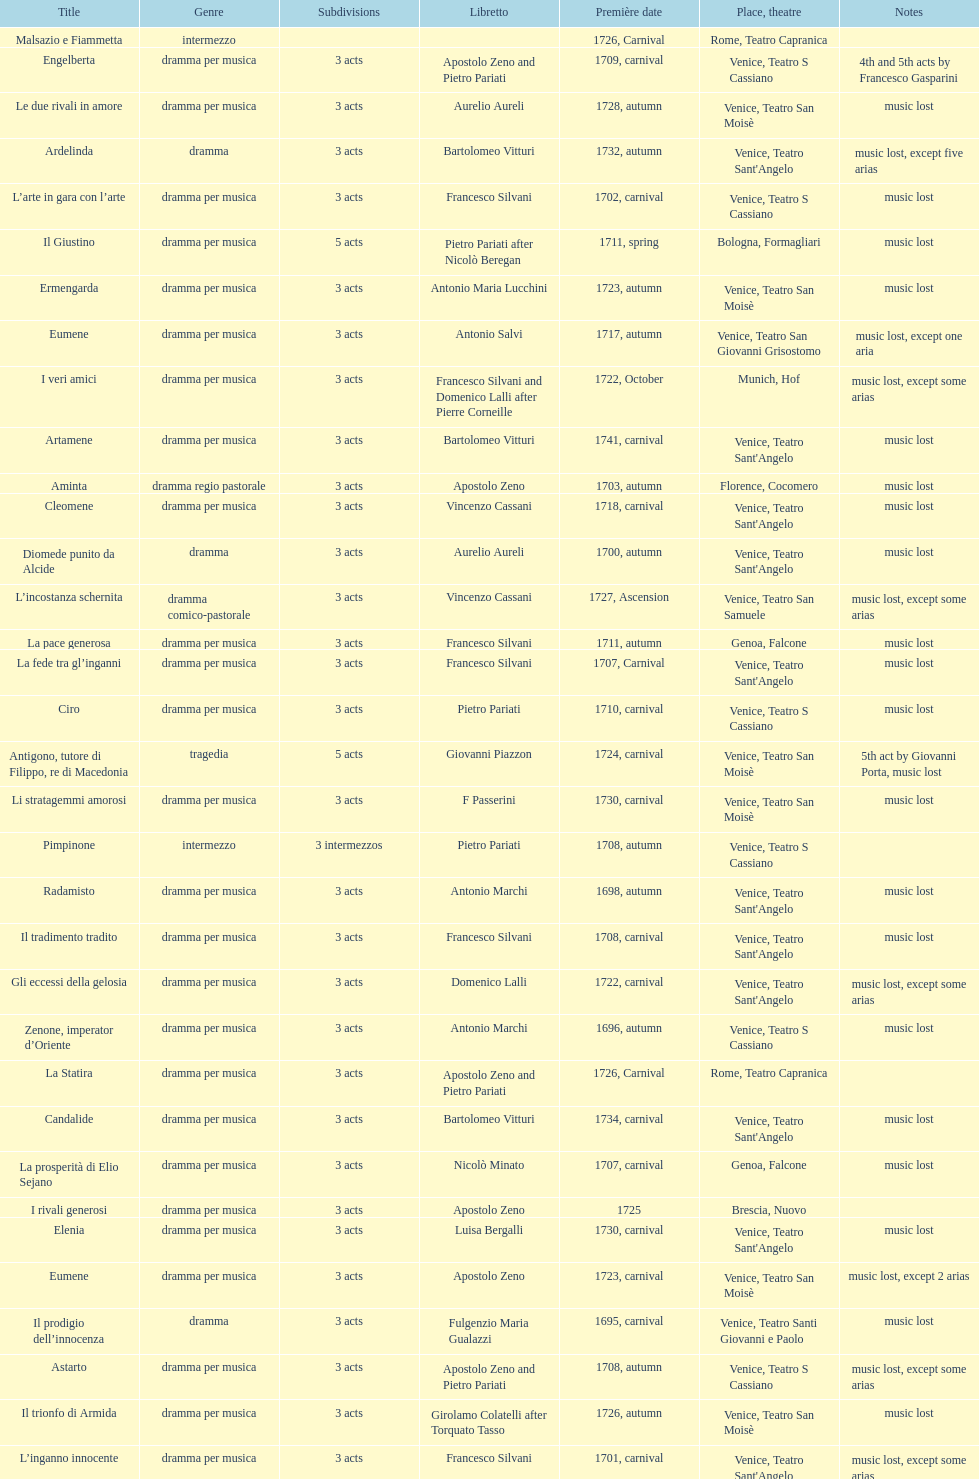Which opera has at least 5 acts? Il Giustino. Help me parse the entirety of this table. {'header': ['Title', 'Genre', 'Sub\xaddivisions', 'Libretto', 'Première date', 'Place, theatre', 'Notes'], 'rows': [['Malsazio e Fiammetta', 'intermezzo', '', '', '1726, Carnival', 'Rome, Teatro Capranica', ''], ['Engelberta', 'dramma per musica', '3 acts', 'Apostolo Zeno and Pietro Pariati', '1709, carnival', 'Venice, Teatro S Cassiano', '4th and 5th acts by Francesco Gasparini'], ['Le due rivali in amore', 'dramma per musica', '3 acts', 'Aurelio Aureli', '1728, autumn', 'Venice, Teatro San Moisè', 'music lost'], ['Ardelinda', 'dramma', '3 acts', 'Bartolomeo Vitturi', '1732, autumn', "Venice, Teatro Sant'Angelo", 'music lost, except five arias'], ['L’arte in gara con l’arte', 'dramma per musica', '3 acts', 'Francesco Silvani', '1702, carnival', 'Venice, Teatro S Cassiano', 'music lost'], ['Il Giustino', 'dramma per musica', '5 acts', 'Pietro Pariati after Nicolò Beregan', '1711, spring', 'Bologna, Formagliari', 'music lost'], ['Ermengarda', 'dramma per musica', '3 acts', 'Antonio Maria Lucchini', '1723, autumn', 'Venice, Teatro San Moisè', 'music lost'], ['Eumene', 'dramma per musica', '3 acts', 'Antonio Salvi', '1717, autumn', 'Venice, Teatro San Giovanni Grisostomo', 'music lost, except one aria'], ['I veri amici', 'dramma per musica', '3 acts', 'Francesco Silvani and Domenico Lalli after Pierre Corneille', '1722, October', 'Munich, Hof', 'music lost, except some arias'], ['Artamene', 'dramma per musica', '3 acts', 'Bartolomeo Vitturi', '1741, carnival', "Venice, Teatro Sant'Angelo", 'music lost'], ['Aminta', 'dramma regio pastorale', '3 acts', 'Apostolo Zeno', '1703, autumn', 'Florence, Cocomero', 'music lost'], ['Cleomene', 'dramma per musica', '3 acts', 'Vincenzo Cassani', '1718, carnival', "Venice, Teatro Sant'Angelo", 'music lost'], ['Diomede punito da Alcide', 'dramma', '3 acts', 'Aurelio Aureli', '1700, autumn', "Venice, Teatro Sant'Angelo", 'music lost'], ['L’incostanza schernita', 'dramma comico-pastorale', '3 acts', 'Vincenzo Cassani', '1727, Ascension', 'Venice, Teatro San Samuele', 'music lost, except some arias'], ['La pace generosa', 'dramma per musica', '3 acts', 'Francesco Silvani', '1711, autumn', 'Genoa, Falcone', 'music lost'], ['La fede tra gl’inganni', 'dramma per musica', '3 acts', 'Francesco Silvani', '1707, Carnival', "Venice, Teatro Sant'Angelo", 'music lost'], ['Ciro', 'dramma per musica', '3 acts', 'Pietro Pariati', '1710, carnival', 'Venice, Teatro S Cassiano', 'music lost'], ['Antigono, tutore di Filippo, re di Macedonia', 'tragedia', '5 acts', 'Giovanni Piazzon', '1724, carnival', 'Venice, Teatro San Moisè', '5th act by Giovanni Porta, music lost'], ['Li stratagemmi amorosi', 'dramma per musica', '3 acts', 'F Passerini', '1730, carnival', 'Venice, Teatro San Moisè', 'music lost'], ['Pimpinone', 'intermezzo', '3 intermezzos', 'Pietro Pariati', '1708, autumn', 'Venice, Teatro S Cassiano', ''], ['Radamisto', 'dramma per musica', '3 acts', 'Antonio Marchi', '1698, autumn', "Venice, Teatro Sant'Angelo", 'music lost'], ['Il tradimento tradito', 'dramma per musica', '3 acts', 'Francesco Silvani', '1708, carnival', "Venice, Teatro Sant'Angelo", 'music lost'], ['Gli eccessi della gelosia', 'dramma per musica', '3 acts', 'Domenico Lalli', '1722, carnival', "Venice, Teatro Sant'Angelo", 'music lost, except some arias'], ['Zenone, imperator d’Oriente', 'dramma per musica', '3 acts', 'Antonio Marchi', '1696, autumn', 'Venice, Teatro S Cassiano', 'music lost'], ['La Statira', 'dramma per musica', '3 acts', 'Apostolo Zeno and Pietro Pariati', '1726, Carnival', 'Rome, Teatro Capranica', ''], ['Candalide', 'dramma per musica', '3 acts', 'Bartolomeo Vitturi', '1734, carnival', "Venice, Teatro Sant'Angelo", 'music lost'], ['La prosperità di Elio Sejano', 'dramma per musica', '3 acts', 'Nicolò Minato', '1707, carnival', 'Genoa, Falcone', 'music lost'], ['I rivali generosi', 'dramma per musica', '3 acts', 'Apostolo Zeno', '1725', 'Brescia, Nuovo', ''], ['Elenia', 'dramma per musica', '3 acts', 'Luisa Bergalli', '1730, carnival', "Venice, Teatro Sant'Angelo", 'music lost'], ['Eumene', 'dramma per musica', '3 acts', 'Apostolo Zeno', '1723, carnival', 'Venice, Teatro San Moisè', 'music lost, except 2 arias'], ['Il prodigio dell’innocenza', 'dramma', '3 acts', 'Fulgenzio Maria Gualazzi', '1695, carnival', 'Venice, Teatro Santi Giovanni e Paolo', 'music lost'], ['Astarto', 'dramma per musica', '3 acts', 'Apostolo Zeno and Pietro Pariati', '1708, autumn', 'Venice, Teatro S Cassiano', 'music lost, except some arias'], ['Il trionfo di Armida', 'dramma per musica', '3 acts', 'Girolamo Colatelli after Torquato Tasso', '1726, autumn', 'Venice, Teatro San Moisè', 'music lost'], ['L’inganno innocente', 'dramma per musica', '3 acts', 'Francesco Silvani', '1701, carnival', "Venice, Teatro Sant'Angelo", 'music lost, except some arias'], ['Il trionfo d’amore', 'dramma per musica', '3 acts', 'Pietro Pariati', '1722, November', 'Munich', 'music lost'], ['Zenobia, regina de’ Palmireni', 'dramma per musica', '3 acts', 'Antonio Marchi', '1694, carnival', 'Venice, Teatro Santi Giovanni e Paolo', 'version of the score survives in Library of Congress, Washington'], ['Merope', 'dramma', '3 acts', 'Apostolo Zeno', '1731, autumn', 'Prague, Sporck Theater', 'mostly by Albinoni, music lost'], ["L'impresario delle Isole Canarie", 'intermezzo', '2 acts', 'Metastasio', '1725, carnival', 'Venice, Teatro S Cassiano', 'music lost'], ['Il Tigrane, re d’Armenia', 'dramma per musica', '3 acts', 'Giulio Cesare Corradi', '1697, carnival', 'Venice, Teatro S Cassiano', 'music lost'], ['Il tiranno eroe', 'dramma per musica', '3 acts', 'Vincenzo Cassani', '1711, carnival', 'Venice, Teatro S Cassiano', ''], ['Lucio Vero', 'dramma per musica', '3 acts', 'Apostolo Zeno', '1713, spring', 'Ferrara, S Stefano', 'music lost'], ['Meleagro', 'dramma per musica', '3 acts', 'Pietro Antonio Bernardoni', '1718, carnival', "Venice, Teatro Sant'Angelo", 'music lost'], ['Primislao, primo re di Boemia', 'dramma per musica', '3 acts', 'Giulio Cesare Corradi', '1697, autumn', 'Venice, Teatro S Cassiano', 'music lost'], ['Didone abbandonata', 'tragedia', '3 acts', 'Metastasio', '1725, carnival', 'Venice, Teatro S Cassiano', 'music lost'], ['Alcina delusa da Ruggero', 'dramma per musica', '3 acts', 'Antonio Marchi', '1725, autumn', 'Venice, Teatro S Cassiano', 'music lost'], ['Il più fedel tra i vassalli', 'dramma per musica', '3 acts', 'Francesco Silvani', '1705, autumn', 'Genoa, Falcone', 'music lost'], ['La fortezza al cimento', 'melodramma', '2 acts', 'Francesco Silvani', '1707', 'Piacenza, Ducale', 'music lost'], ["L'amor di figlio non conosciuto", 'dramma per musica', '3 acts', 'Domenico Lalli', '1716, carnival', "Venice, Teatro Sant'Angelo", 'music lost'], ['L’ingratitudine castigata', 'dramma per musica', '3 acts', 'Francesco Silvani', '1698, carnival', 'Venice, Teatro S Cassiano', 'music lost'], ['Il più infedel tra gli amanti', 'dramma per musica', '3 acts', 'Angelo Schietti', '1731, autumn', 'Treviso, Dolphin', 'music lost'], ['Laodice', 'dramma per musica', '3 acts', 'Angelo Schietti', '1724, autumn', 'Venice, Teatro San Moisè', 'music lost, except 2 arias'], ['Il Satrapone', 'intermezzo', '', 'Salvi', '1729', 'Parma, Omodeo', ''], ['Scipione nelle Spagne', 'dramma per musica', '3 acts', 'Apostolo Zeno', '1724, Ascension', 'Venice, Teatro San Samuele', 'music lost'], ['Le gare generose', 'dramma per musica', '3 acts', 'Antonio Zaniboni', '1712, autumn', 'Venice, Teatro S Cassiano', 'music lost, except five arias'], ['Griselda', 'dramma per musica', '3 acts', 'Apostolo Zeno', '1703, carnival', 'Florence, Cocomero', 'music lost, except three arias']]} 